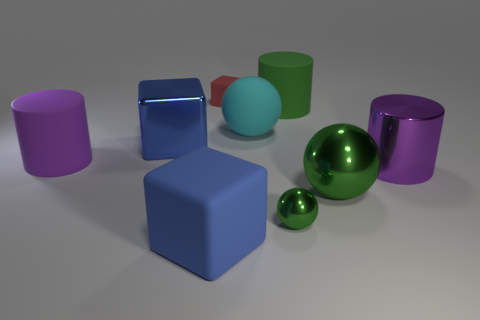Add 1 large green spheres. How many objects exist? 10 Subtract all spheres. How many objects are left? 6 Add 6 small red cylinders. How many small red cylinders exist? 6 Subtract 1 green cylinders. How many objects are left? 8 Subtract all green rubber blocks. Subtract all metal cubes. How many objects are left? 8 Add 6 blue rubber objects. How many blue rubber objects are left? 7 